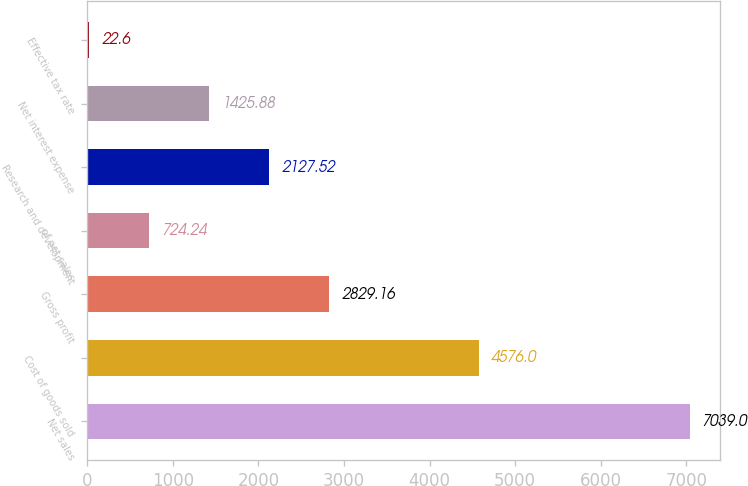Convert chart. <chart><loc_0><loc_0><loc_500><loc_500><bar_chart><fcel>Net sales<fcel>Cost of goods sold<fcel>Gross profit<fcel>of net sales<fcel>Research and development<fcel>Net interest expense<fcel>Effective tax rate<nl><fcel>7039<fcel>4576<fcel>2829.16<fcel>724.24<fcel>2127.52<fcel>1425.88<fcel>22.6<nl></chart> 